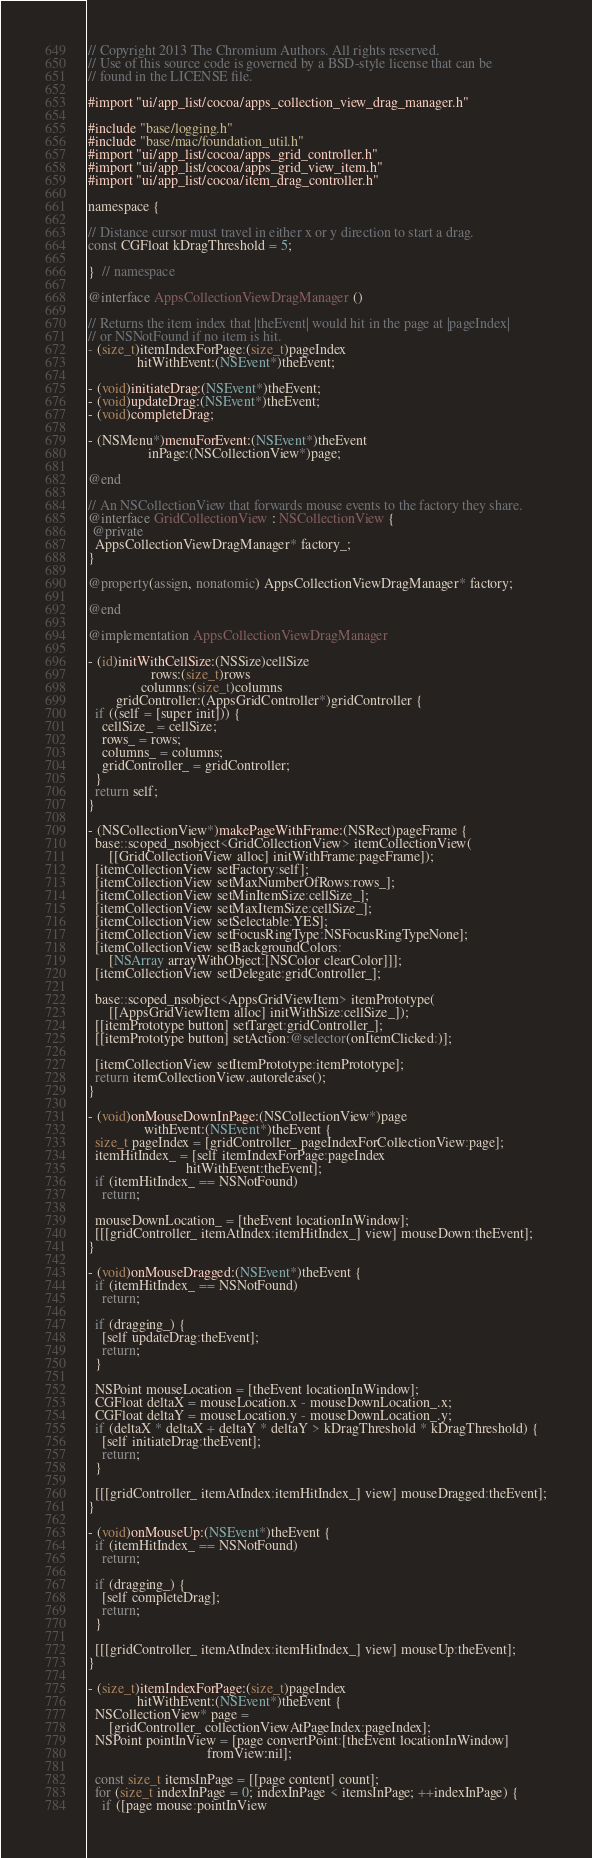<code> <loc_0><loc_0><loc_500><loc_500><_ObjectiveC_>// Copyright 2013 The Chromium Authors. All rights reserved.
// Use of this source code is governed by a BSD-style license that can be
// found in the LICENSE file.

#import "ui/app_list/cocoa/apps_collection_view_drag_manager.h"

#include "base/logging.h"
#include "base/mac/foundation_util.h"
#import "ui/app_list/cocoa/apps_grid_controller.h"
#import "ui/app_list/cocoa/apps_grid_view_item.h"
#import "ui/app_list/cocoa/item_drag_controller.h"

namespace {

// Distance cursor must travel in either x or y direction to start a drag.
const CGFloat kDragThreshold = 5;

}  // namespace

@interface AppsCollectionViewDragManager ()

// Returns the item index that |theEvent| would hit in the page at |pageIndex|
// or NSNotFound if no item is hit.
- (size_t)itemIndexForPage:(size_t)pageIndex
              hitWithEvent:(NSEvent*)theEvent;

- (void)initiateDrag:(NSEvent*)theEvent;
- (void)updateDrag:(NSEvent*)theEvent;
- (void)completeDrag;

- (NSMenu*)menuForEvent:(NSEvent*)theEvent
                 inPage:(NSCollectionView*)page;

@end

// An NSCollectionView that forwards mouse events to the factory they share.
@interface GridCollectionView : NSCollectionView {
 @private
  AppsCollectionViewDragManager* factory_;
}

@property(assign, nonatomic) AppsCollectionViewDragManager* factory;

@end

@implementation AppsCollectionViewDragManager

- (id)initWithCellSize:(NSSize)cellSize
                  rows:(size_t)rows
               columns:(size_t)columns
        gridController:(AppsGridController*)gridController {
  if ((self = [super init])) {
    cellSize_ = cellSize;
    rows_ = rows;
    columns_ = columns;
    gridController_ = gridController;
  }
  return self;
}

- (NSCollectionView*)makePageWithFrame:(NSRect)pageFrame {
  base::scoped_nsobject<GridCollectionView> itemCollectionView(
      [[GridCollectionView alloc] initWithFrame:pageFrame]);
  [itemCollectionView setFactory:self];
  [itemCollectionView setMaxNumberOfRows:rows_];
  [itemCollectionView setMinItemSize:cellSize_];
  [itemCollectionView setMaxItemSize:cellSize_];
  [itemCollectionView setSelectable:YES];
  [itemCollectionView setFocusRingType:NSFocusRingTypeNone];
  [itemCollectionView setBackgroundColors:
      [NSArray arrayWithObject:[NSColor clearColor]]];
  [itemCollectionView setDelegate:gridController_];

  base::scoped_nsobject<AppsGridViewItem> itemPrototype(
      [[AppsGridViewItem alloc] initWithSize:cellSize_]);
  [[itemPrototype button] setTarget:gridController_];
  [[itemPrototype button] setAction:@selector(onItemClicked:)];

  [itemCollectionView setItemPrototype:itemPrototype];
  return itemCollectionView.autorelease();
}

- (void)onMouseDownInPage:(NSCollectionView*)page
                withEvent:(NSEvent*)theEvent {
  size_t pageIndex = [gridController_ pageIndexForCollectionView:page];
  itemHitIndex_ = [self itemIndexForPage:pageIndex
                            hitWithEvent:theEvent];
  if (itemHitIndex_ == NSNotFound)
    return;

  mouseDownLocation_ = [theEvent locationInWindow];
  [[[gridController_ itemAtIndex:itemHitIndex_] view] mouseDown:theEvent];
}

- (void)onMouseDragged:(NSEvent*)theEvent {
  if (itemHitIndex_ == NSNotFound)
    return;

  if (dragging_) {
    [self updateDrag:theEvent];
    return;
  }

  NSPoint mouseLocation = [theEvent locationInWindow];
  CGFloat deltaX = mouseLocation.x - mouseDownLocation_.x;
  CGFloat deltaY = mouseLocation.y - mouseDownLocation_.y;
  if (deltaX * deltaX + deltaY * deltaY > kDragThreshold * kDragThreshold) {
    [self initiateDrag:theEvent];
    return;
  }

  [[[gridController_ itemAtIndex:itemHitIndex_] view] mouseDragged:theEvent];
}

- (void)onMouseUp:(NSEvent*)theEvent {
  if (itemHitIndex_ == NSNotFound)
    return;

  if (dragging_) {
    [self completeDrag];
    return;
  }

  [[[gridController_ itemAtIndex:itemHitIndex_] view] mouseUp:theEvent];
}

- (size_t)itemIndexForPage:(size_t)pageIndex
              hitWithEvent:(NSEvent*)theEvent {
  NSCollectionView* page =
      [gridController_ collectionViewAtPageIndex:pageIndex];
  NSPoint pointInView = [page convertPoint:[theEvent locationInWindow]
                                  fromView:nil];

  const size_t itemsInPage = [[page content] count];
  for (size_t indexInPage = 0; indexInPage < itemsInPage; ++indexInPage) {
    if ([page mouse:pointInView</code> 